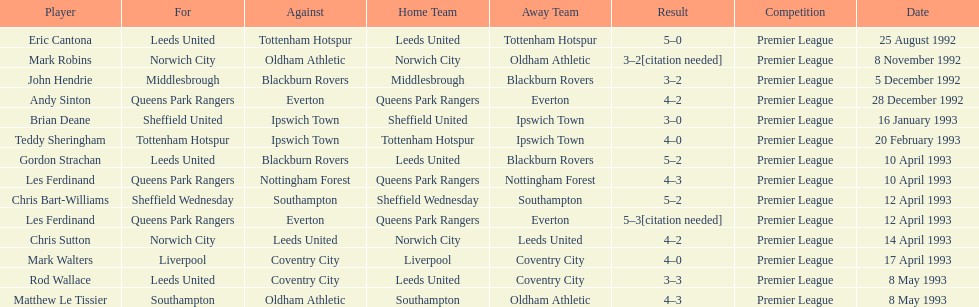What was the result of the match between queens park rangers and everton? 4-2. 